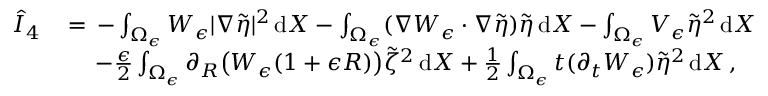<formula> <loc_0><loc_0><loc_500><loc_500>\begin{array} { r l } { \hat { I } _ { 4 } \, } & { = \, - \int _ { \Omega _ { \epsilon } } W _ { \epsilon } | \nabla \tilde { \eta } | ^ { 2 } \, d X - \int _ { \Omega _ { \epsilon } } ( \nabla W _ { \epsilon } \cdot \nabla \tilde { \eta } ) \tilde { \eta } \, d X - \int _ { \Omega _ { \epsilon } } V _ { \epsilon } \tilde { \eta } ^ { 2 } \, d X } \\ & { \quad \, - \frac { \epsilon } { 2 } \int _ { \Omega _ { \epsilon } } \partial _ { R } \left ( W _ { \epsilon } ( 1 + \epsilon R ) \right ) \tilde { \zeta } ^ { 2 } \, d X + \frac { 1 } { 2 } \int _ { \Omega _ { \epsilon } } t ( \partial _ { t } W _ { \epsilon } ) \tilde { \eta } ^ { 2 } \, d X \, , } \end{array}</formula> 